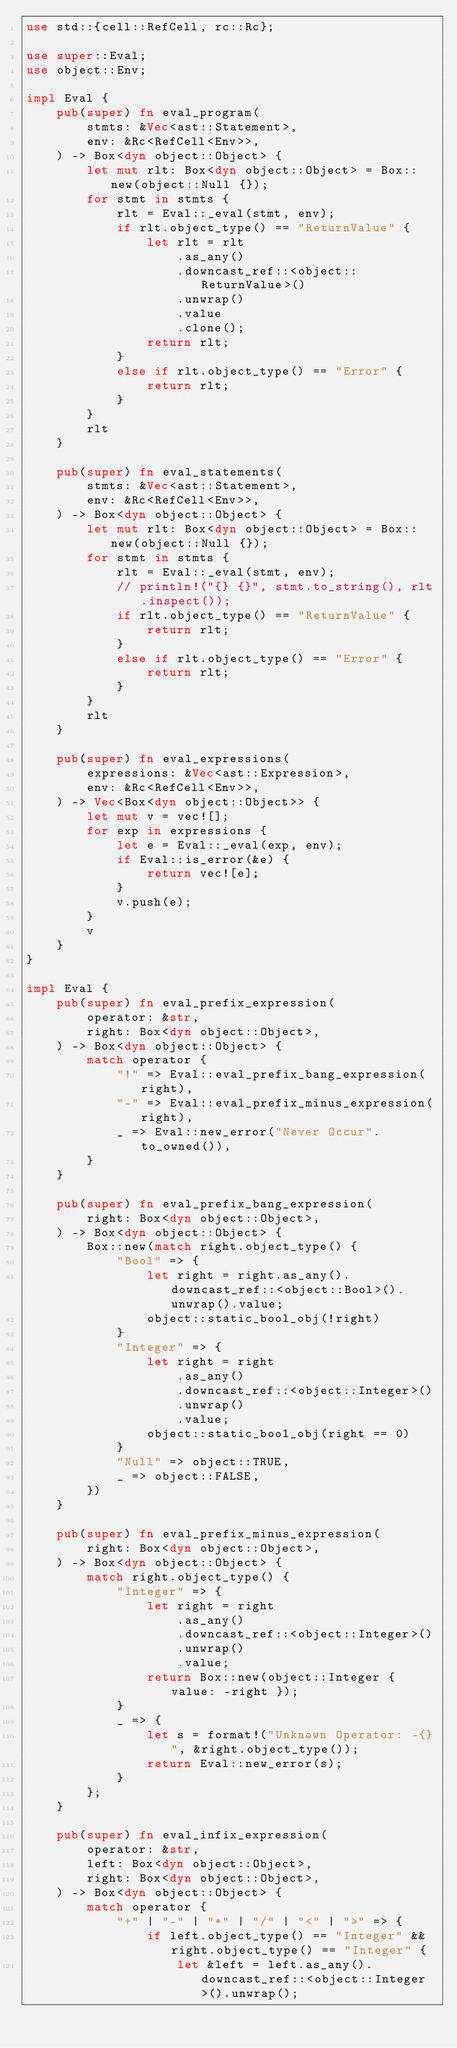Convert code to text. <code><loc_0><loc_0><loc_500><loc_500><_Rust_>use std::{cell::RefCell, rc::Rc};

use super::Eval;
use object::Env;

impl Eval {
    pub(super) fn eval_program(
        stmts: &Vec<ast::Statement>,
        env: &Rc<RefCell<Env>>,
    ) -> Box<dyn object::Object> {
        let mut rlt: Box<dyn object::Object> = Box::new(object::Null {});
        for stmt in stmts {
            rlt = Eval::_eval(stmt, env);
            if rlt.object_type() == "ReturnValue" {
                let rlt = rlt
                    .as_any()
                    .downcast_ref::<object::ReturnValue>()
                    .unwrap()
                    .value
                    .clone();
                return rlt;
            }
            else if rlt.object_type() == "Error" {
                return rlt;
            }
        }
        rlt
    }

    pub(super) fn eval_statements(
        stmts: &Vec<ast::Statement>,
        env: &Rc<RefCell<Env>>,
    ) -> Box<dyn object::Object> {
        let mut rlt: Box<dyn object::Object> = Box::new(object::Null {});
        for stmt in stmts {
            rlt = Eval::_eval(stmt, env);
            // println!("{} {}", stmt.to_string(), rlt.inspect());
            if rlt.object_type() == "ReturnValue" {
                return rlt;
            }
            else if rlt.object_type() == "Error" {
                return rlt;
            }
        }
        rlt
    }

    pub(super) fn eval_expressions(
        expressions: &Vec<ast::Expression>,
        env: &Rc<RefCell<Env>>,
    ) -> Vec<Box<dyn object::Object>> {
        let mut v = vec![];
        for exp in expressions {
            let e = Eval::_eval(exp, env);
            if Eval::is_error(&e) {
                return vec![e];
            }
            v.push(e);
        }
        v
    }
}

impl Eval {
    pub(super) fn eval_prefix_expression(
        operator: &str,
        right: Box<dyn object::Object>,
    ) -> Box<dyn object::Object> {
        match operator {
            "!" => Eval::eval_prefix_bang_expression(right),
            "-" => Eval::eval_prefix_minus_expression(right),
            _ => Eval::new_error("Never Occur".to_owned()),
        }
    }

    pub(super) fn eval_prefix_bang_expression(
        right: Box<dyn object::Object>,
    ) -> Box<dyn object::Object> {
        Box::new(match right.object_type() {
            "Bool" => {
                let right = right.as_any().downcast_ref::<object::Bool>().unwrap().value;
                object::static_bool_obj(!right)
            }
            "Integer" => {
                let right = right
                    .as_any()
                    .downcast_ref::<object::Integer>()
                    .unwrap()
                    .value;
                object::static_bool_obj(right == 0)
            }
            "Null" => object::TRUE,
            _ => object::FALSE,
        })
    }

    pub(super) fn eval_prefix_minus_expression(
        right: Box<dyn object::Object>,
    ) -> Box<dyn object::Object> {
        match right.object_type() {
            "Integer" => {
                let right = right
                    .as_any()
                    .downcast_ref::<object::Integer>()
                    .unwrap()
                    .value;
                return Box::new(object::Integer { value: -right });
            }
            _ => {
                let s = format!("Unknown Operator: -{}", &right.object_type());
                return Eval::new_error(s);
            }
        };
    }

    pub(super) fn eval_infix_expression(
        operator: &str,
        left: Box<dyn object::Object>,
        right: Box<dyn object::Object>,
    ) -> Box<dyn object::Object> {
        match operator {
            "+" | "-" | "*" | "/" | "<" | ">" => {
                if left.object_type() == "Integer" && right.object_type() == "Integer" {
                    let &left = left.as_any().downcast_ref::<object::Integer>().unwrap();</code> 